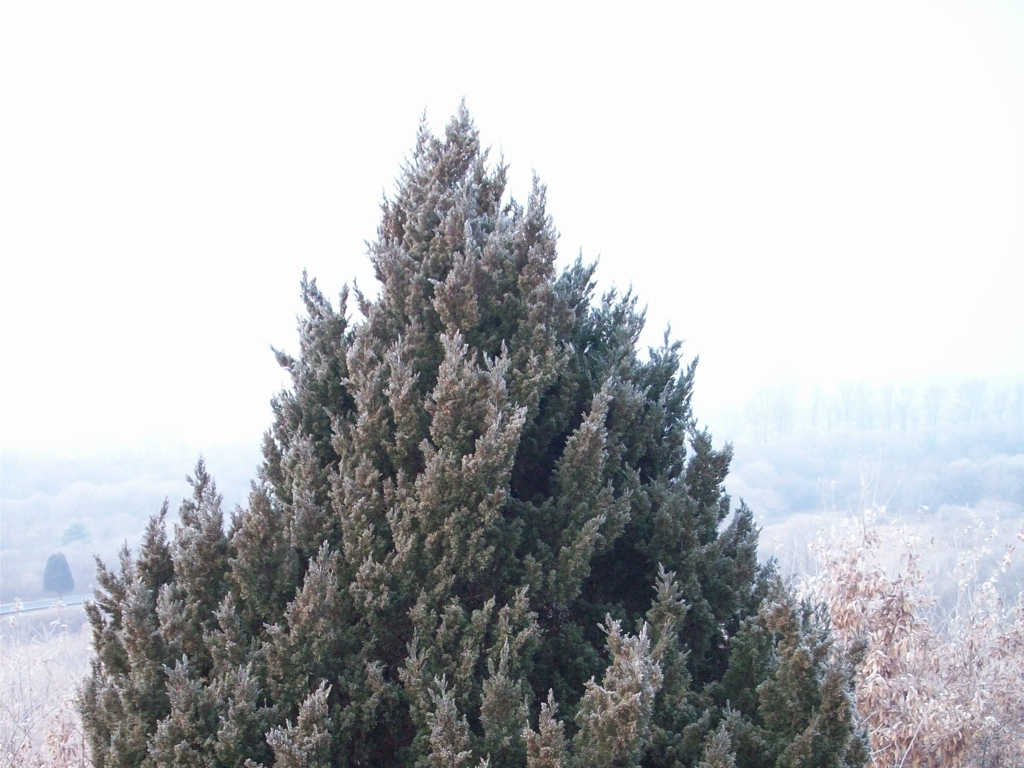What time of year does this image appear to depict and why? The image seems to depict a scene from the winter season. This can be inferred from the frost seen on the branches of the coniferous tree, which commonly occurs during colder weather when moisture in the air freezes upon surfaces. The overall subdued color palette and the haziness in the background also contribute to the wintry atmosphere of the scene. 